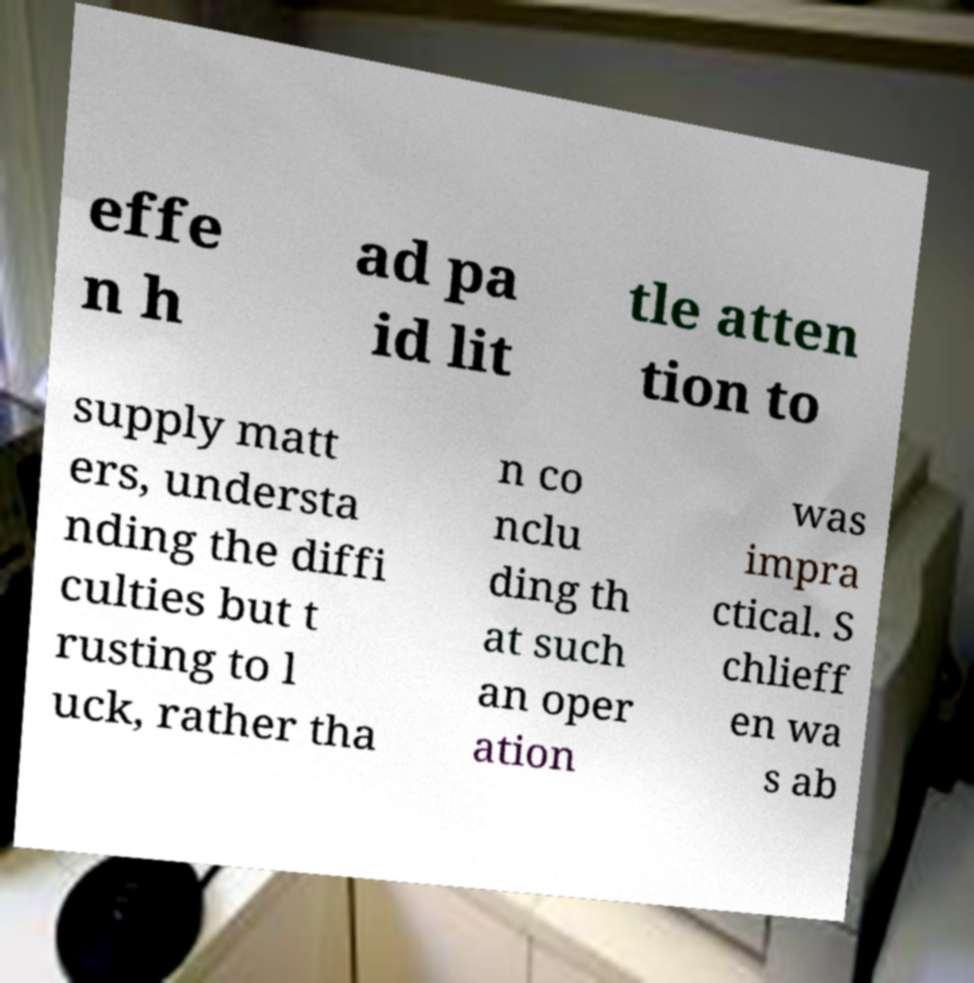Please identify and transcribe the text found in this image. effe n h ad pa id lit tle atten tion to supply matt ers, understa nding the diffi culties but t rusting to l uck, rather tha n co nclu ding th at such an oper ation was impra ctical. S chlieff en wa s ab 